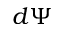Convert formula to latex. <formula><loc_0><loc_0><loc_500><loc_500>d \Psi</formula> 